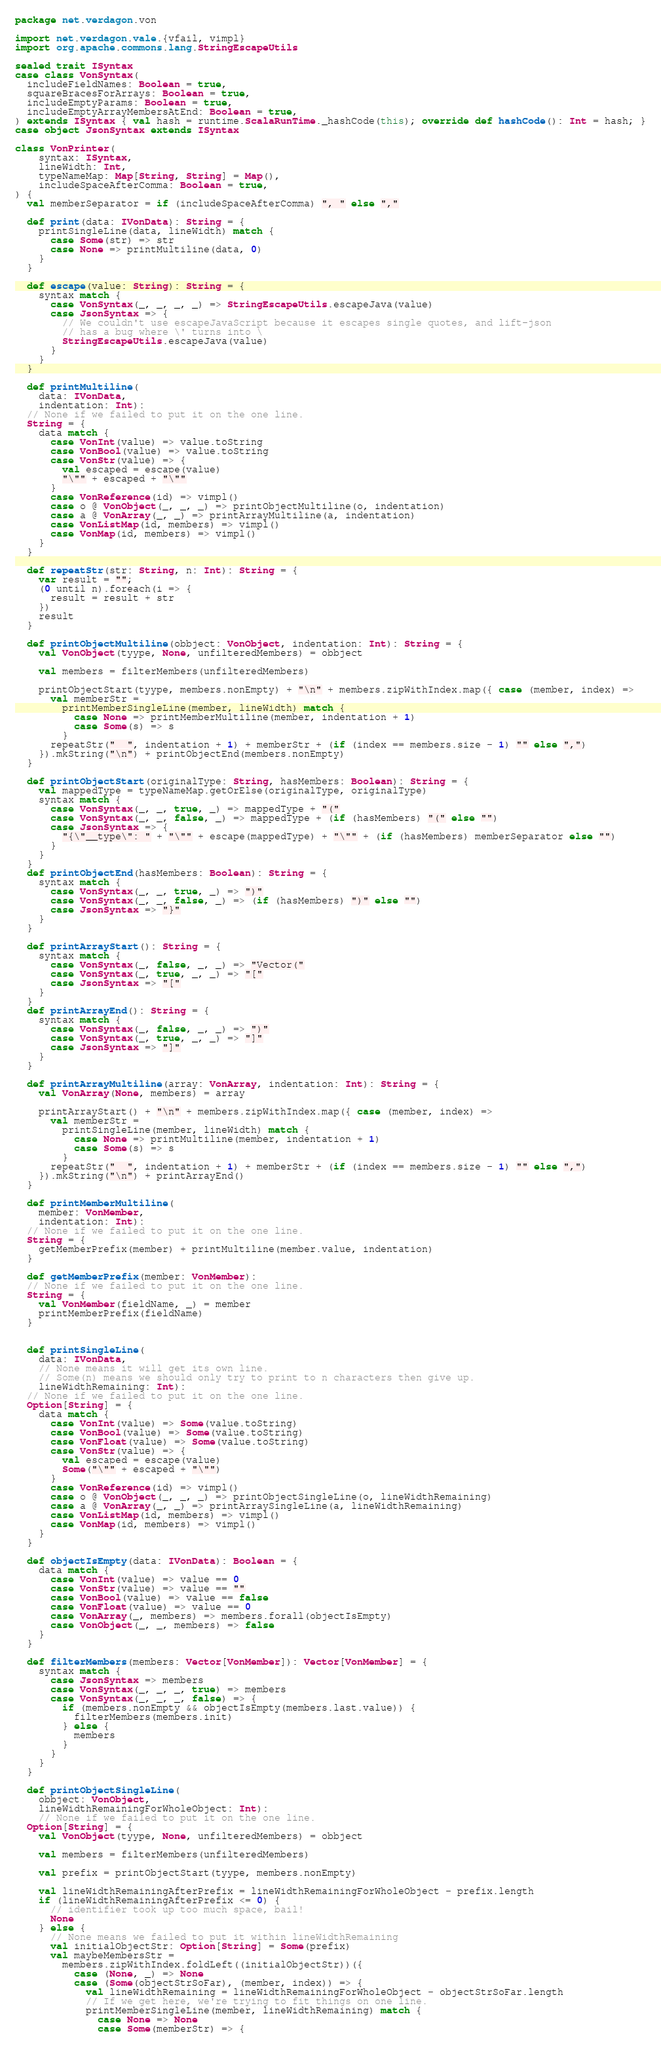Convert code to text. <code><loc_0><loc_0><loc_500><loc_500><_Scala_>package net.verdagon.von

import net.verdagon.vale.{vfail, vimpl}
import org.apache.commons.lang.StringEscapeUtils

sealed trait ISyntax
case class VonSyntax(
  includeFieldNames: Boolean = true,
  squareBracesForArrays: Boolean = true,
  includeEmptyParams: Boolean = true,
  includeEmptyArrayMembersAtEnd: Boolean = true,
) extends ISyntax { val hash = runtime.ScalaRunTime._hashCode(this); override def hashCode(): Int = hash; }
case object JsonSyntax extends ISyntax

class VonPrinter(
    syntax: ISyntax,
    lineWidth: Int,
    typeNameMap: Map[String, String] = Map(),
    includeSpaceAfterComma: Boolean = true,
) {
  val memberSeparator = if (includeSpaceAfterComma) ", " else ","

  def print(data: IVonData): String = {
    printSingleLine(data, lineWidth) match {
      case Some(str) => str
      case None => printMultiline(data, 0)
    }
  }

  def escape(value: String): String = {
    syntax match {
      case VonSyntax(_, _, _, _) => StringEscapeUtils.escapeJava(value)
      case JsonSyntax => {
        // We couldn't use escapeJavaScript because it escapes single quotes, and lift-json
        // has a bug where \' turns into \
        StringEscapeUtils.escapeJava(value)
      }
    }
  }

  def printMultiline(
    data: IVonData,
    indentation: Int):
  // None if we failed to put it on the one line.
  String = {
    data match {
      case VonInt(value) => value.toString
      case VonBool(value) => value.toString
      case VonStr(value) => {
        val escaped = escape(value)
        "\"" + escaped + "\""
      }
      case VonReference(id) => vimpl()
      case o @ VonObject(_, _, _) => printObjectMultiline(o, indentation)
      case a @ VonArray(_, _) => printArrayMultiline(a, indentation)
      case VonListMap(id, members) => vimpl()
      case VonMap(id, members) => vimpl()
    }
  }

  def repeatStr(str: String, n: Int): String = {
    var result = "";
    (0 until n).foreach(i => {
      result = result + str
    })
    result
  }

  def printObjectMultiline(obbject: VonObject, indentation: Int): String = {
    val VonObject(tyype, None, unfilteredMembers) = obbject

    val members = filterMembers(unfilteredMembers)

    printObjectStart(tyype, members.nonEmpty) + "\n" + members.zipWithIndex.map({ case (member, index) =>
      val memberStr =
        printMemberSingleLine(member, lineWidth) match {
          case None => printMemberMultiline(member, indentation + 1)
          case Some(s) => s
        }
      repeatStr("  ", indentation + 1) + memberStr + (if (index == members.size - 1) "" else ",")
    }).mkString("\n") + printObjectEnd(members.nonEmpty)
  }

  def printObjectStart(originalType: String, hasMembers: Boolean): String = {
    val mappedType = typeNameMap.getOrElse(originalType, originalType)
    syntax match {
      case VonSyntax(_, _, true, _) => mappedType + "("
      case VonSyntax(_, _, false, _) => mappedType + (if (hasMembers) "(" else "")
      case JsonSyntax => {
        "{\"__type\": " + "\"" + escape(mappedType) + "\"" + (if (hasMembers) memberSeparator else "")
      }
    }
  }
  def printObjectEnd(hasMembers: Boolean): String = {
    syntax match {
      case VonSyntax(_, _, true, _) => ")"
      case VonSyntax(_, _, false, _) => (if (hasMembers) ")" else "")
      case JsonSyntax => "}"
    }
  }

  def printArrayStart(): String = {
    syntax match {
      case VonSyntax(_, false, _, _) => "Vector("
      case VonSyntax(_, true, _, _) => "["
      case JsonSyntax => "["
    }
  }
  def printArrayEnd(): String = {
    syntax match {
      case VonSyntax(_, false, _, _) => ")"
      case VonSyntax(_, true, _, _) => "]"
      case JsonSyntax => "]"
    }
  }

  def printArrayMultiline(array: VonArray, indentation: Int): String = {
    val VonArray(None, members) = array

    printArrayStart() + "\n" + members.zipWithIndex.map({ case (member, index) =>
      val memberStr =
        printSingleLine(member, lineWidth) match {
          case None => printMultiline(member, indentation + 1)
          case Some(s) => s
        }
      repeatStr("  ", indentation + 1) + memberStr + (if (index == members.size - 1) "" else ",")
    }).mkString("\n") + printArrayEnd()
  }

  def printMemberMultiline(
    member: VonMember,
    indentation: Int):
  // None if we failed to put it on the one line.
  String = {
    getMemberPrefix(member) + printMultiline(member.value, indentation)
  }

  def getMemberPrefix(member: VonMember):
  // None if we failed to put it on the one line.
  String = {
    val VonMember(fieldName, _) = member
    printMemberPrefix(fieldName)
  }


  def printSingleLine(
    data: IVonData,
    // None means it will get its own line.
    // Some(n) means we should only try to print to n characters then give up.
    lineWidthRemaining: Int):
  // None if we failed to put it on the one line.
  Option[String] = {
    data match {
      case VonInt(value) => Some(value.toString)
      case VonBool(value) => Some(value.toString)
      case VonFloat(value) => Some(value.toString)
      case VonStr(value) => {
        val escaped = escape(value)
        Some("\"" + escaped + "\"")
      }
      case VonReference(id) => vimpl()
      case o @ VonObject(_, _, _) => printObjectSingleLine(o, lineWidthRemaining)
      case a @ VonArray(_, _) => printArraySingleLine(a, lineWidthRemaining)
      case VonListMap(id, members) => vimpl()
      case VonMap(id, members) => vimpl()
    }
  }

  def objectIsEmpty(data: IVonData): Boolean = {
    data match {
      case VonInt(value) => value == 0
      case VonStr(value) => value == ""
      case VonBool(value) => value == false
      case VonFloat(value) => value == 0
      case VonArray(_, members) => members.forall(objectIsEmpty)
      case VonObject(_, _, members) => false
    }
  }

  def filterMembers(members: Vector[VonMember]): Vector[VonMember] = {
    syntax match {
      case JsonSyntax => members
      case VonSyntax(_, _, _, true) => members
      case VonSyntax(_, _, _, false) => {
        if (members.nonEmpty && objectIsEmpty(members.last.value)) {
          filterMembers(members.init)
        } else {
          members
        }
      }
    }
  }

  def printObjectSingleLine(
    obbject: VonObject,
    lineWidthRemainingForWholeObject: Int):
    // None if we failed to put it on the one line.
  Option[String] = {
    val VonObject(tyype, None, unfilteredMembers) = obbject

    val members = filterMembers(unfilteredMembers)

    val prefix = printObjectStart(tyype, members.nonEmpty)

    val lineWidthRemainingAfterPrefix = lineWidthRemainingForWholeObject - prefix.length
    if (lineWidthRemainingAfterPrefix <= 0) {
      // identifier took up too much space, bail!
      None
    } else {
      // None means we failed to put it within lineWidthRemaining
      val initialObjectStr: Option[String] = Some(prefix)
      val maybeMembersStr =
        members.zipWithIndex.foldLeft((initialObjectStr))({
          case (None, _) => None
          case (Some(objectStrSoFar), (member, index)) => {
            val lineWidthRemaining = lineWidthRemainingForWholeObject - objectStrSoFar.length
            // If we get here, we're trying to fit things on one line.
            printMemberSingleLine(member, lineWidthRemaining) match {
              case None => None
              case Some(memberStr) => {</code> 